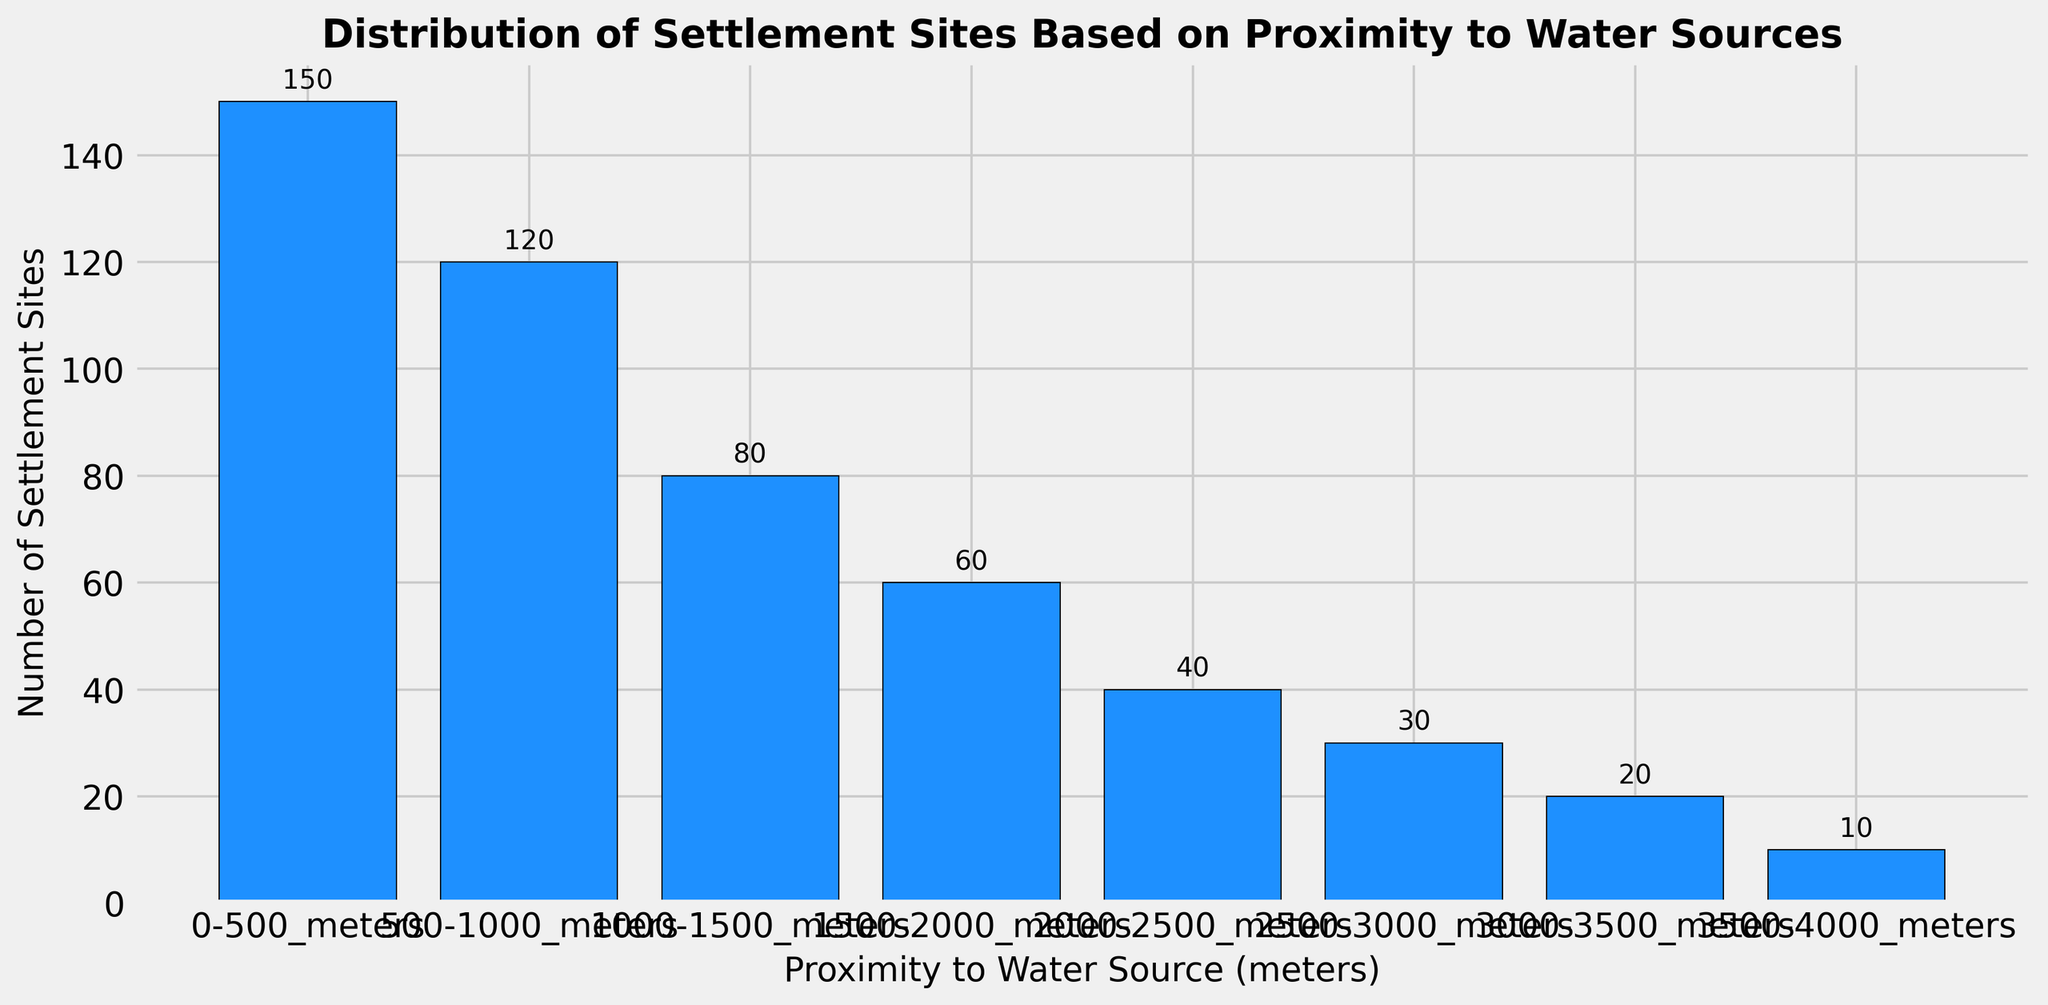What's the total number of settlement sites within 1000 meters of water sources? Sum the number of settlement sites within 0-500 meters and 500-1000 meters. Total = 150 + 120 = 270
Answer: 270 Which proximity range has the fewest settlement sites? Look for the bar with the smallest height, which represents the range with the fewest settlement sites.
Answer: 3500-4000 meters How does the number of settlement sites change as the distance from water sources increases? Observe the trend of the bar heights. The number of settlement sites decreases as the distance increases.
Answer: Decreases Which proximity range has the largest number of settlement sites? Identify the bar with the greatest height, representing the highest number of settlement sites.
Answer: 0-500 meters What's the difference in the number of settlement sites between the 0-500 meters range and the 2000-2500 meters range? Subtract the number of settlement sites in the 2000-2500 meters range from the number in the 0-500 meters range. 150 - 40 = 110
Answer: 110 How many settlement sites are there between 1000 meters and 3000 meters from water sources? Add the number of settlement sites in the 1000-1500 meters, 1500-2000 meters, 2000-2500 meters, and 2500-3000 meters ranges. 80 + 60 + 40 + 30 = 210
Answer: 210 Which proximity range has three times as many settlement sites as the 3000-3500 meters range? Multiply the number of settlement sites in the 3000-3500 meters range by 3 (3 x 20 = 60). Find the range with 60 sites.
Answer: 1500-2000 meters Is there a proximity range with exactly half the number of settlement sites as the 0-500 meters range? Divide the number of settlement sites in the 0-500 meters range by 2 (150 / 2 = 75). Check the bars to find a range with 75 sites.
Answer: No What is the combined number of settlement sites in the 1500-2000 meters and 2500-3000 meters ranges? Add the number of settlement sites in the 1500-2000 meters range to those in the 2500-3000 meters range. 60 + 30 = 90
Answer: 90 How does the number of settlement sites in the 0-500 meters range compare to the combined total of the 2000-2500 meters and 3500-4000 meters ranges? Compute the combined total for 2000-2500 meters and 3500-4000 meters (40 + 10 = 50). Compare it to 150. 150 > 50.
Answer: More 